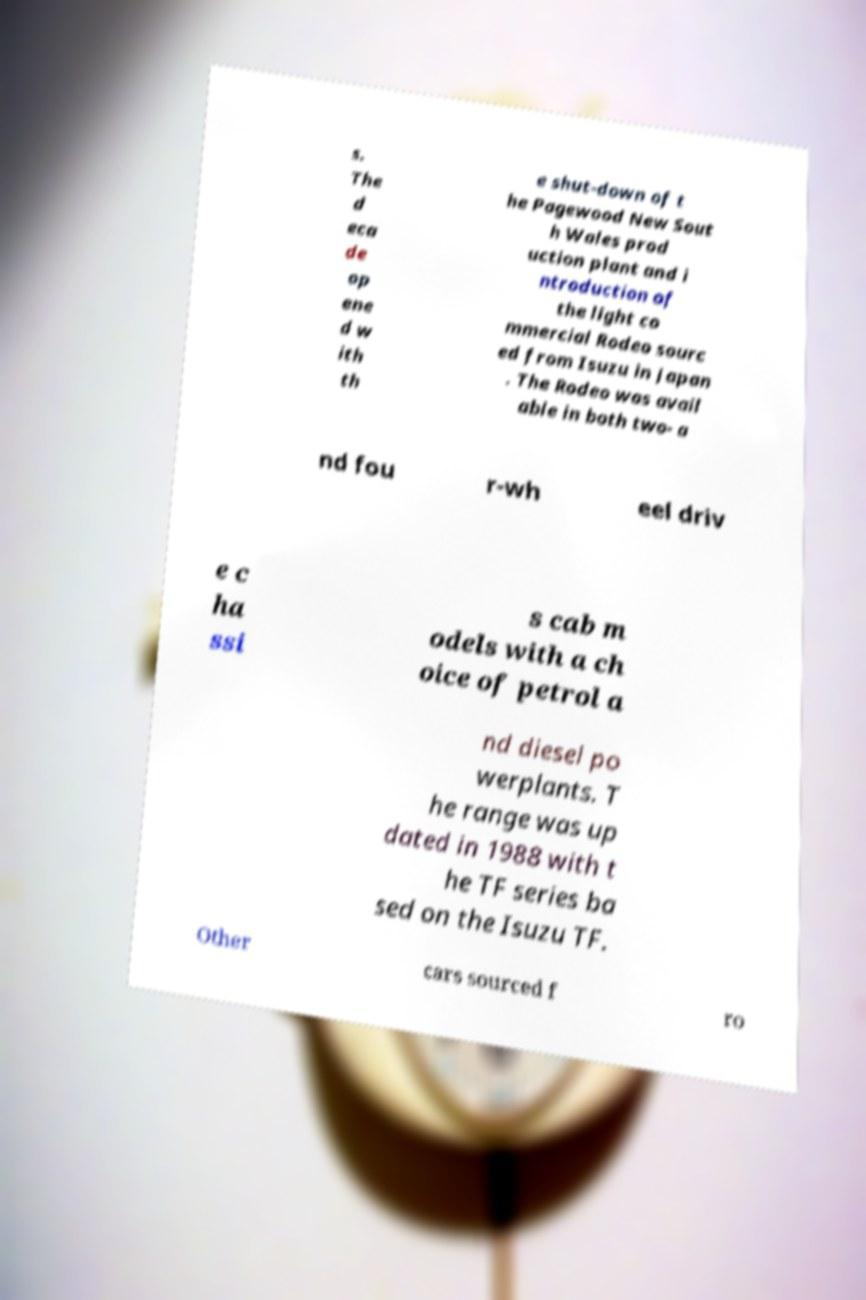Please identify and transcribe the text found in this image. s. The d eca de op ene d w ith th e shut-down of t he Pagewood New Sout h Wales prod uction plant and i ntroduction of the light co mmercial Rodeo sourc ed from Isuzu in Japan . The Rodeo was avail able in both two- a nd fou r-wh eel driv e c ha ssi s cab m odels with a ch oice of petrol a nd diesel po werplants. T he range was up dated in 1988 with t he TF series ba sed on the Isuzu TF. Other cars sourced f ro 